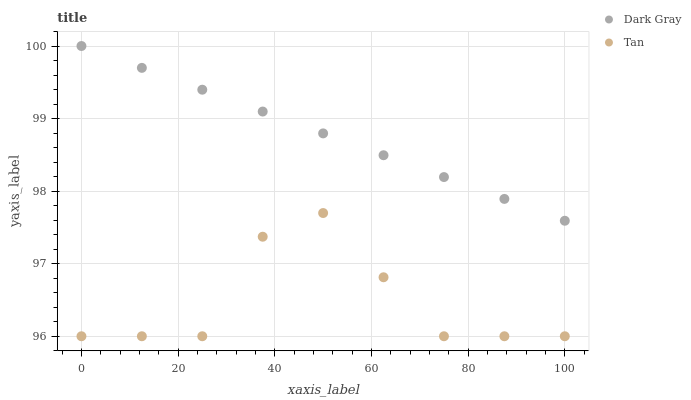Does Tan have the minimum area under the curve?
Answer yes or no. Yes. Does Dark Gray have the maximum area under the curve?
Answer yes or no. Yes. Does Tan have the maximum area under the curve?
Answer yes or no. No. Is Dark Gray the smoothest?
Answer yes or no. Yes. Is Tan the roughest?
Answer yes or no. Yes. Is Tan the smoothest?
Answer yes or no. No. Does Tan have the lowest value?
Answer yes or no. Yes. Does Dark Gray have the highest value?
Answer yes or no. Yes. Does Tan have the highest value?
Answer yes or no. No. Is Tan less than Dark Gray?
Answer yes or no. Yes. Is Dark Gray greater than Tan?
Answer yes or no. Yes. Does Tan intersect Dark Gray?
Answer yes or no. No. 